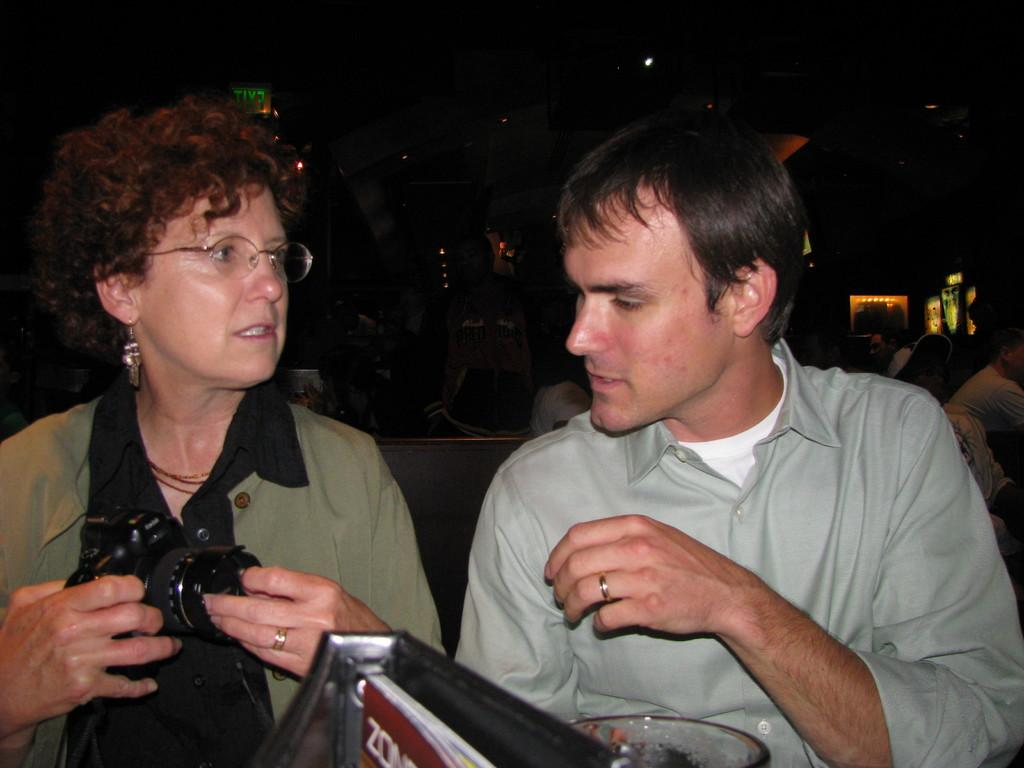How many people are in the image? There are two persons in the image. Where are the two persons located in the image? The two persons are at the foreground of the image. What is the lady person holding in the image? The lady person is holding a camera at the left side of the image. What type of pie is being served on the legs of the person on the right side of the image? There is no pie or legs visible in the image; it only features two persons, one of whom is holding a camera. 